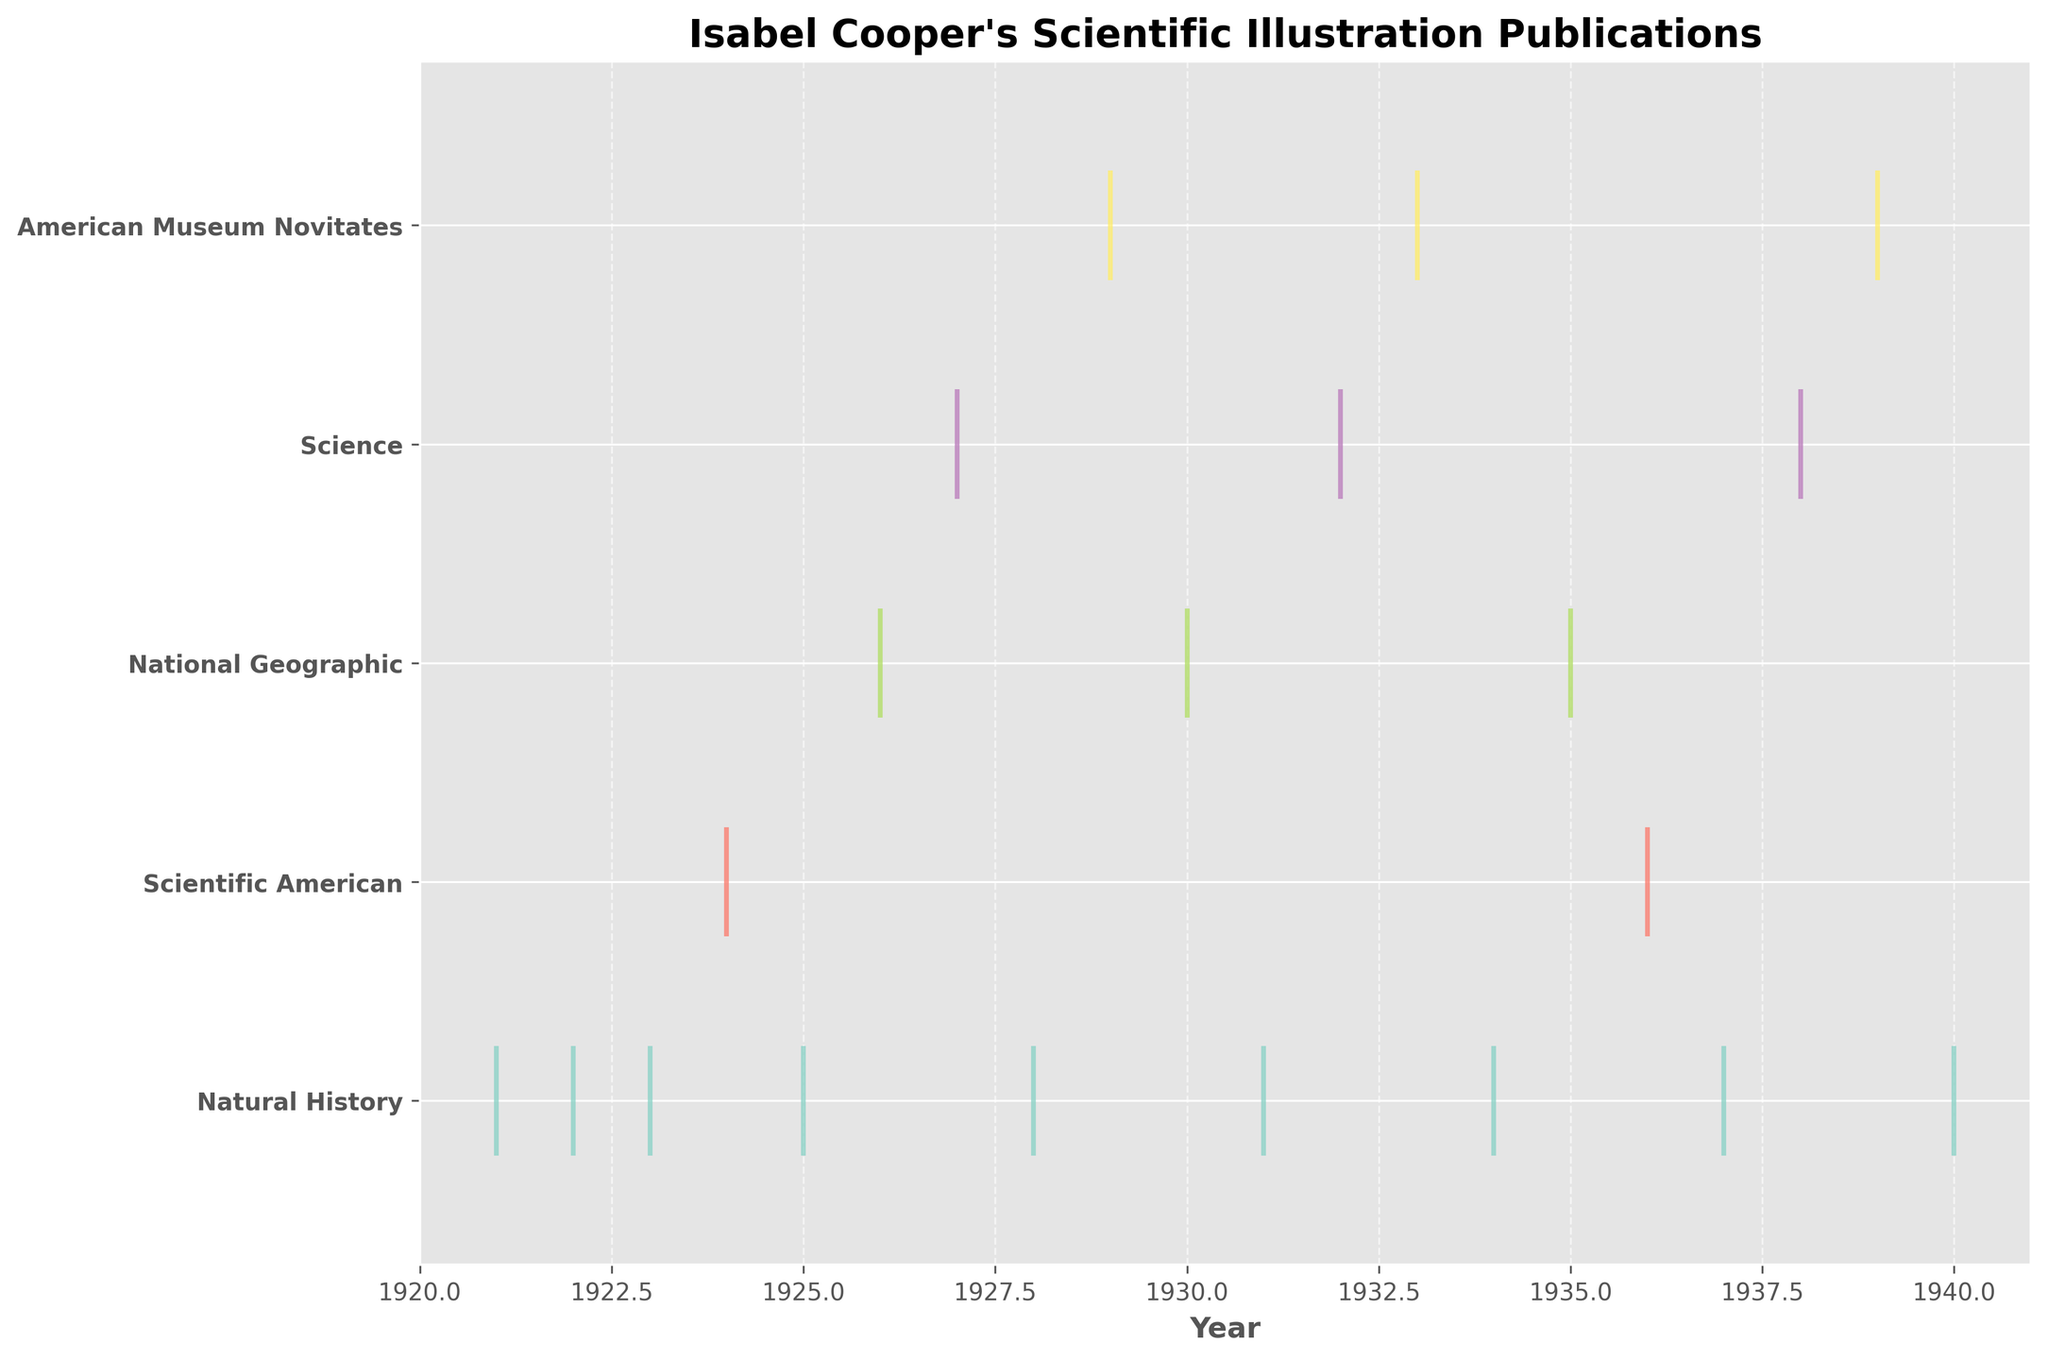How many journals are represented in the figure? The unique journal names can be identified visually from the y-axis labels, which list all the journals.
Answer: 5 Which journal has the most publications in the figure? By counting the events (vertical lines) for each journal, it's clear that "Natural History" has the most.
Answer: Natural History In what year did Isabel Cooper first publish in Science based on this figure? By finding the earliest event for Science on the x-axis, the year 1927 is noted.
Answer: 1927 Compare the number of publications in Scientific American and National Geographic. Which one has more? Count the number of events for both journals; National Geographic has more publications than Scientific American.
Answer: National Geographic How many publications are represented for the year 1935? By finding the events corresponding to the year 1935 on the x-axis, it's clear there's one publication.
Answer: 1 What is the range of years shown on the x-axis? The x-axis starts at 1920 and ends at 1941, indicating the range of years.
Answer: 1920 to 1941 How many times did Isabel Cooper publish in American Museum Novitates before 1930? Look at the events for American Museum Novitates before the year 1930. Only one publication is shown for 1929.
Answer: 1 Between 1921 and 1925, in which journal did Isabel Cooper publish the most frequently? Count the number of publications from 1921 to 1925 for each journal; Natural History has the most.
Answer: Natural History Which journal has the fewest publications based on the event plot? By comparing the number of events for each journal, Scientific American has the fewest.
Answer: Scientific American Did Isabel Cooper publish in National Geographic before 1930? There are publication events for National Geographic in both 1926 and 1930, indicating she did publish before 1930.
Answer: Yes 